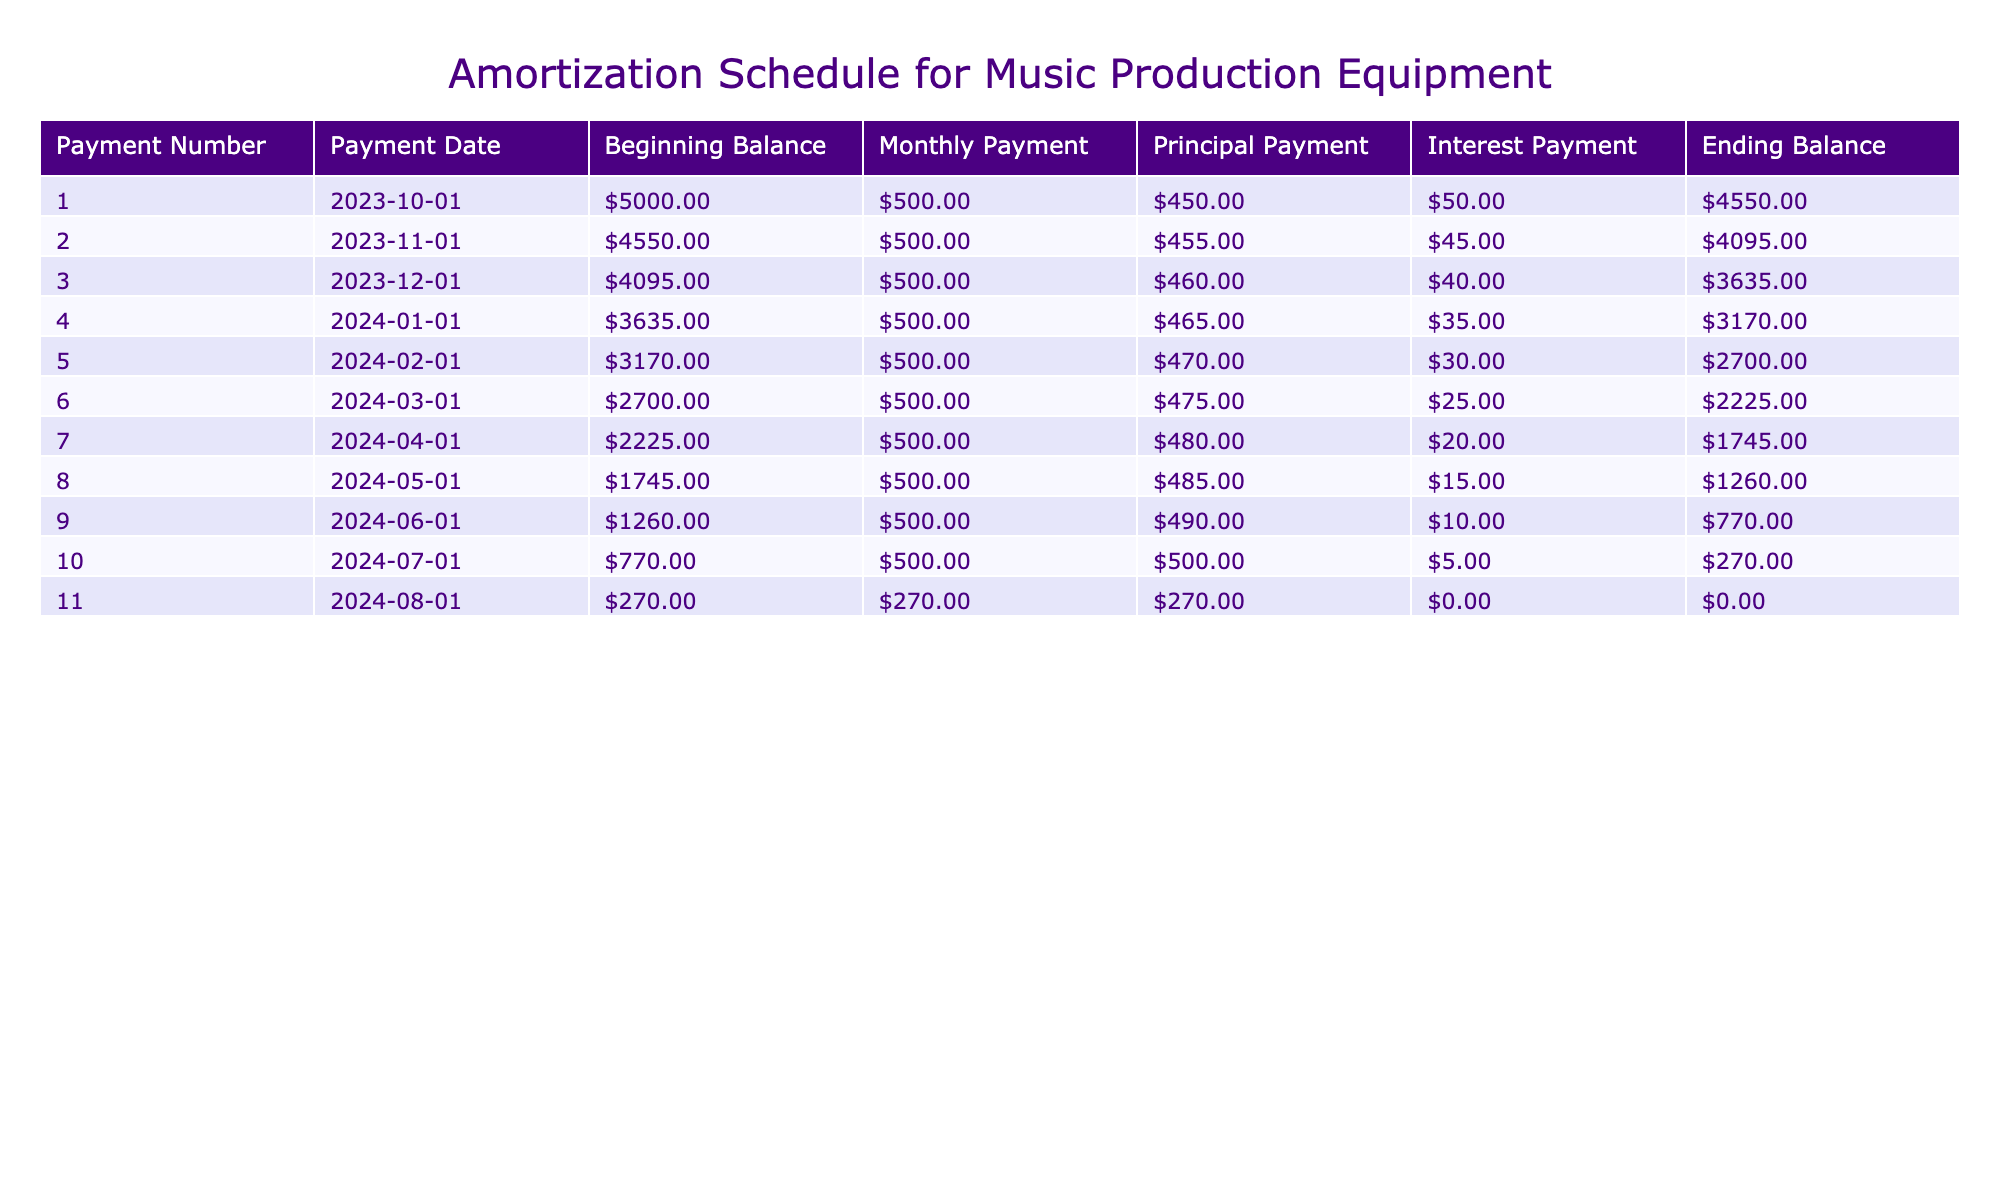What is the total amount paid in the first payment? The first payment is a total of 500, which includes 450 toward the principal and 50 toward interest. Thus, the total amount paid in the first payment is 500.
Answer: 500 How much of the principal is paid off after the second month? To find the principal paid off after the second month, we add the principal payments of both the first and second months: 450 (first month) + 455 (second month) = 905.
Answer: 905 Is the ending balance after the fifth payment less than 3000? The ending balance after the fifth payment is 2700, which is indeed less than 3000. Therefore, the answer is true.
Answer: Yes What is the total interest paid over the entire loan period? The total interest can be found by summing up the interest payments over all periods: 50 + 45 + 40 + 35 + 30 + 25 + 20 + 15 + 10 + 5 + 0 = 275. Therefore, the total interest paid is 275.
Answer: 275 How much did the ending balance decrease from the first month to the last month? The ending balance decreased from 4550 in the first month to 0 in the last month: 4550 - 0 = 4550. Thus, the ending balance decreased by 4550.
Answer: 4550 What was the average principal payment made per month over the loan? To find the average principal payment, we sum all the principal payments (450 + 455 + 460 + 465 + 470 + 475 + 480 + 485 + 490 + 500 + 270) = 5160, then divide by the number of payments (11). Average principal payment = 5160 / 11 ≈ 469.09.
Answer: 469.09 What was the largest monthly payment made during the loan? The largest monthly payment occurred in the last month, which was 270.
Answer: 270 What was the ending balance after the fourth payment? After the fourth payment, the ending balance is 3170. This can be directly retrieved from the table.
Answer: 3170 